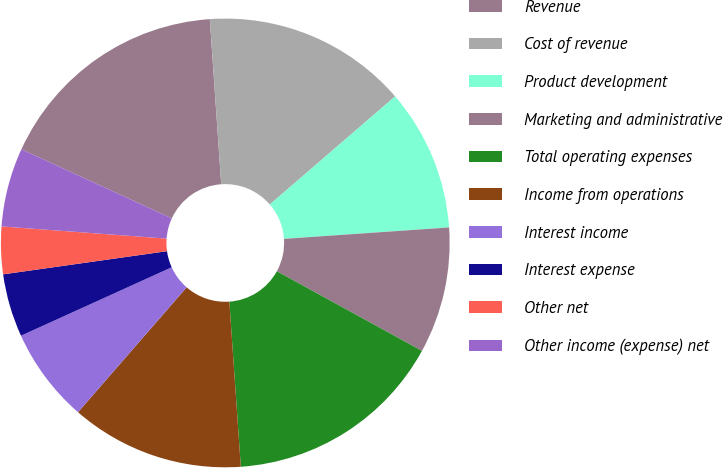<chart> <loc_0><loc_0><loc_500><loc_500><pie_chart><fcel>Revenue<fcel>Cost of revenue<fcel>Product development<fcel>Marketing and administrative<fcel>Total operating expenses<fcel>Income from operations<fcel>Interest income<fcel>Interest expense<fcel>Other net<fcel>Other income (expense) net<nl><fcel>17.05%<fcel>14.77%<fcel>10.23%<fcel>9.09%<fcel>15.91%<fcel>12.5%<fcel>6.82%<fcel>4.55%<fcel>3.41%<fcel>5.68%<nl></chart> 